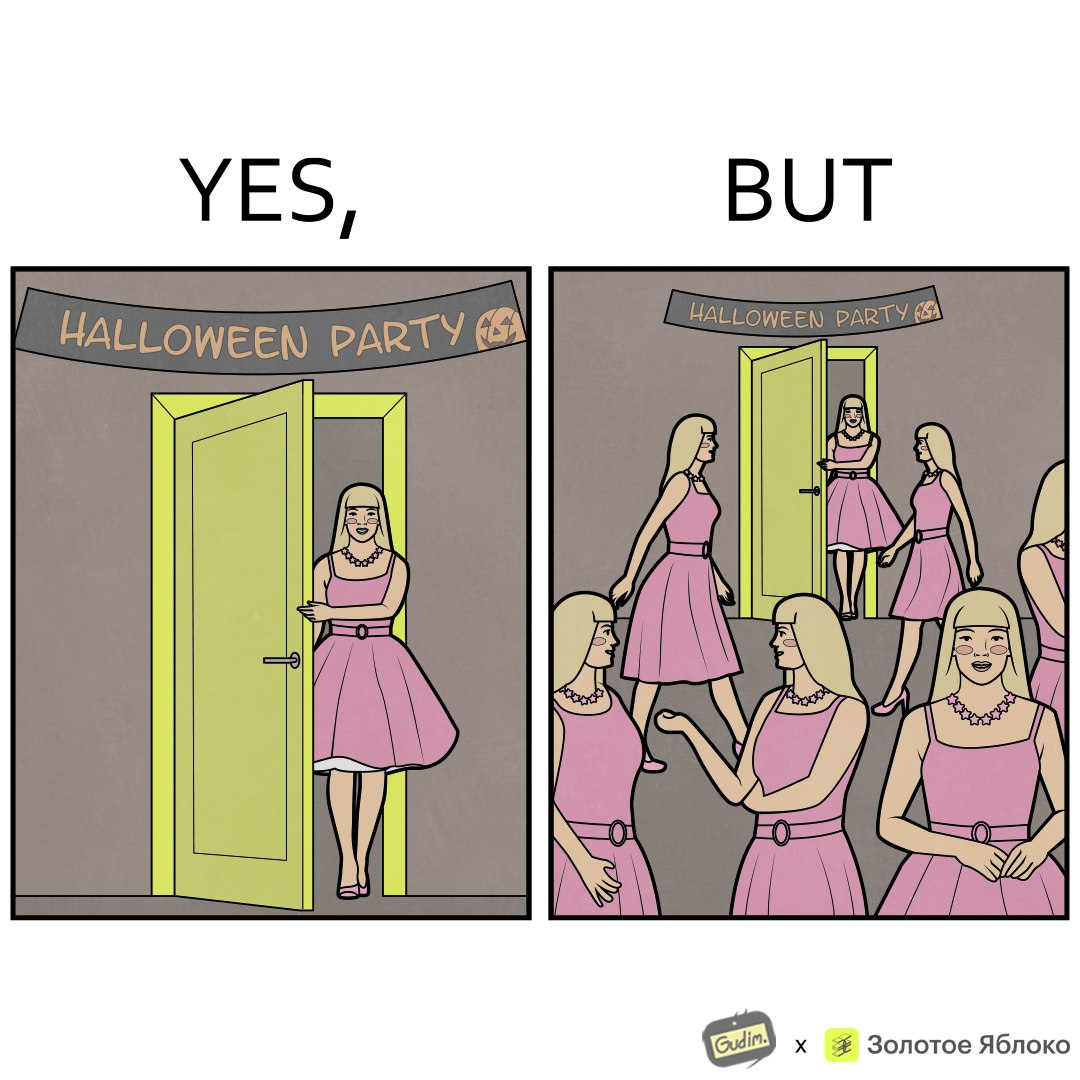What is the satirical meaning behind this image? The image is funny, as the person entering the Halloween Party has a costume that is identical to many other people in the party. 